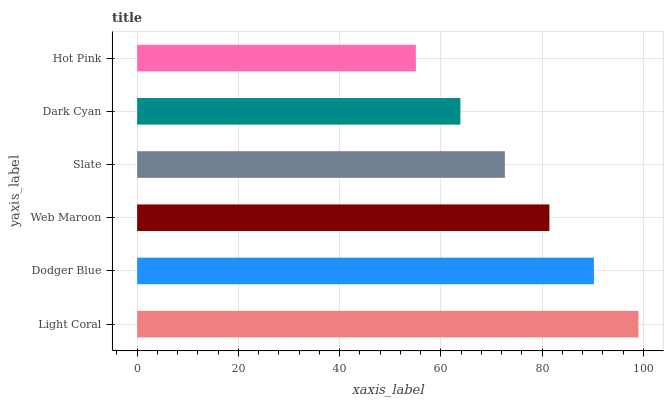Is Hot Pink the minimum?
Answer yes or no. Yes. Is Light Coral the maximum?
Answer yes or no. Yes. Is Dodger Blue the minimum?
Answer yes or no. No. Is Dodger Blue the maximum?
Answer yes or no. No. Is Light Coral greater than Dodger Blue?
Answer yes or no. Yes. Is Dodger Blue less than Light Coral?
Answer yes or no. Yes. Is Dodger Blue greater than Light Coral?
Answer yes or no. No. Is Light Coral less than Dodger Blue?
Answer yes or no. No. Is Web Maroon the high median?
Answer yes or no. Yes. Is Slate the low median?
Answer yes or no. Yes. Is Dark Cyan the high median?
Answer yes or no. No. Is Web Maroon the low median?
Answer yes or no. No. 